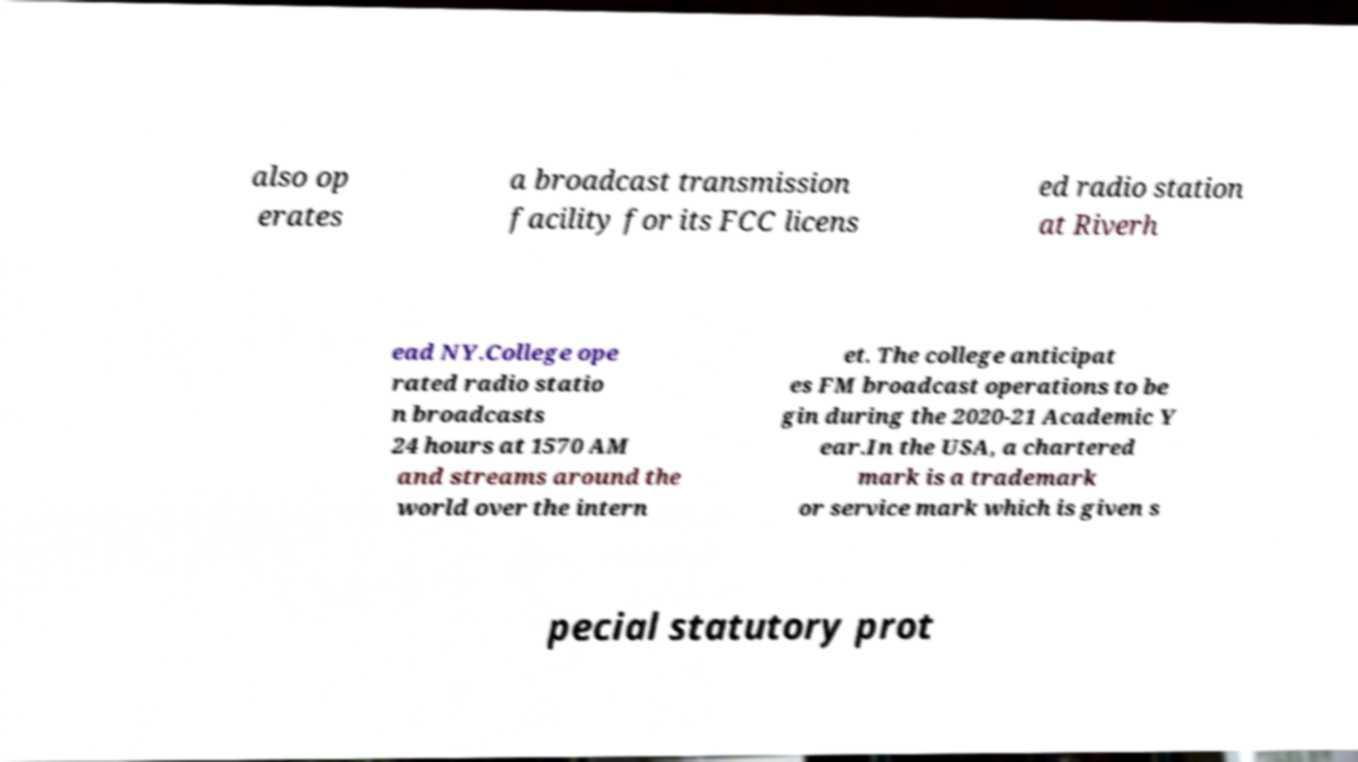Please identify and transcribe the text found in this image. also op erates a broadcast transmission facility for its FCC licens ed radio station at Riverh ead NY.College ope rated radio statio n broadcasts 24 hours at 1570 AM and streams around the world over the intern et. The college anticipat es FM broadcast operations to be gin during the 2020-21 Academic Y ear.In the USA, a chartered mark is a trademark or service mark which is given s pecial statutory prot 